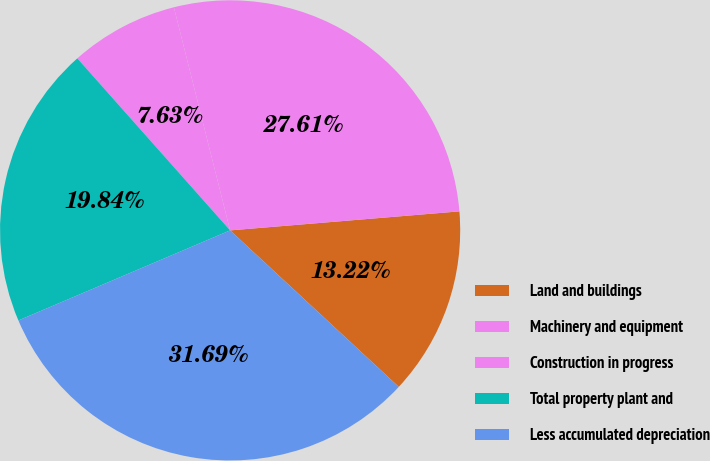Convert chart. <chart><loc_0><loc_0><loc_500><loc_500><pie_chart><fcel>Land and buildings<fcel>Machinery and equipment<fcel>Construction in progress<fcel>Total property plant and<fcel>Less accumulated depreciation<nl><fcel>13.22%<fcel>27.61%<fcel>7.63%<fcel>19.84%<fcel>31.69%<nl></chart> 